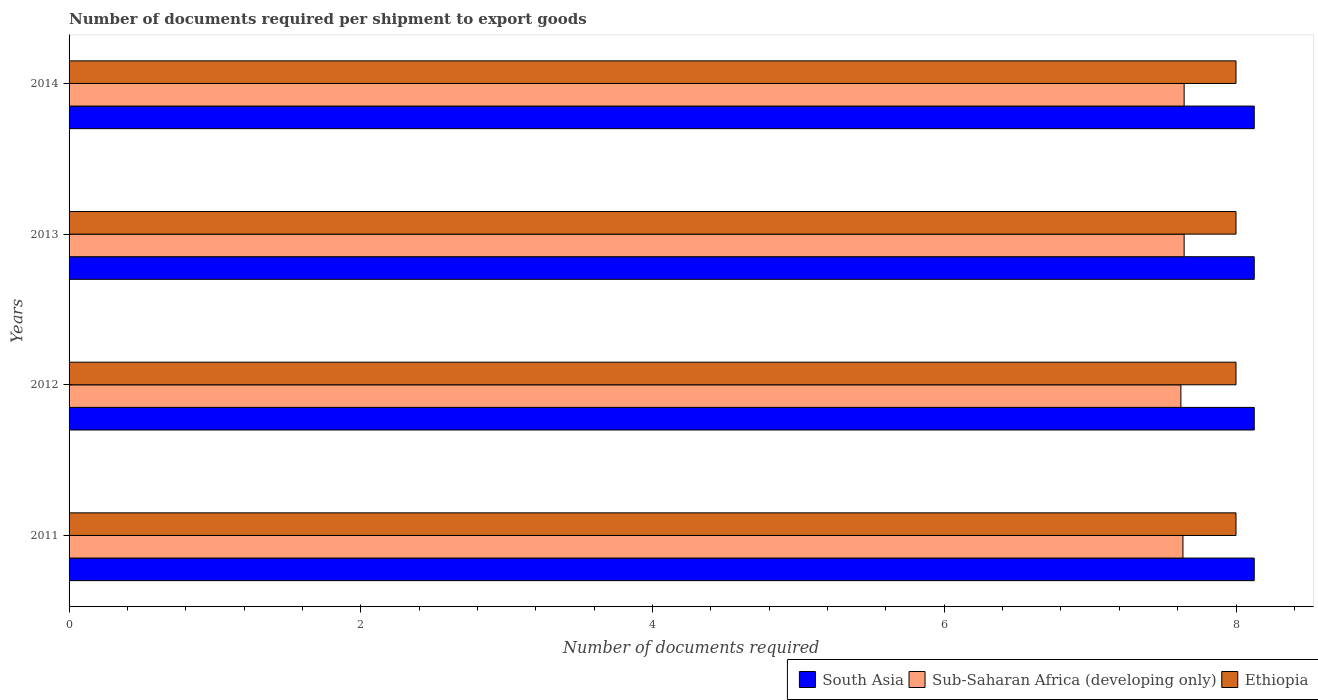How many different coloured bars are there?
Keep it short and to the point. 3. How many groups of bars are there?
Provide a succinct answer. 4. Are the number of bars on each tick of the Y-axis equal?
Make the answer very short. Yes. How many bars are there on the 1st tick from the top?
Ensure brevity in your answer.  3. How many bars are there on the 4th tick from the bottom?
Make the answer very short. 3. What is the label of the 3rd group of bars from the top?
Give a very brief answer. 2012. In how many cases, is the number of bars for a given year not equal to the number of legend labels?
Your answer should be very brief. 0. What is the number of documents required per shipment to export goods in South Asia in 2013?
Give a very brief answer. 8.12. Across all years, what is the maximum number of documents required per shipment to export goods in Sub-Saharan Africa (developing only)?
Offer a terse response. 7.64. Across all years, what is the minimum number of documents required per shipment to export goods in Ethiopia?
Your answer should be very brief. 8. What is the total number of documents required per shipment to export goods in Sub-Saharan Africa (developing only) in the graph?
Give a very brief answer. 30.55. What is the difference between the number of documents required per shipment to export goods in Sub-Saharan Africa (developing only) in 2014 and the number of documents required per shipment to export goods in South Asia in 2012?
Provide a short and direct response. -0.48. What is the average number of documents required per shipment to export goods in Sub-Saharan Africa (developing only) per year?
Offer a very short reply. 7.64. In the year 2014, what is the difference between the number of documents required per shipment to export goods in Sub-Saharan Africa (developing only) and number of documents required per shipment to export goods in Ethiopia?
Your answer should be very brief. -0.36. In how many years, is the number of documents required per shipment to export goods in Ethiopia greater than 7.6 ?
Make the answer very short. 4. Is the number of documents required per shipment to export goods in South Asia in 2012 less than that in 2013?
Provide a short and direct response. No. Is the difference between the number of documents required per shipment to export goods in Sub-Saharan Africa (developing only) in 2013 and 2014 greater than the difference between the number of documents required per shipment to export goods in Ethiopia in 2013 and 2014?
Provide a succinct answer. No. What is the difference between the highest and the lowest number of documents required per shipment to export goods in Sub-Saharan Africa (developing only)?
Your answer should be very brief. 0.02. Is the sum of the number of documents required per shipment to export goods in Sub-Saharan Africa (developing only) in 2012 and 2013 greater than the maximum number of documents required per shipment to export goods in South Asia across all years?
Provide a short and direct response. Yes. What does the 3rd bar from the top in 2013 represents?
Offer a terse response. South Asia. What does the 3rd bar from the bottom in 2014 represents?
Your answer should be compact. Ethiopia. Is it the case that in every year, the sum of the number of documents required per shipment to export goods in Sub-Saharan Africa (developing only) and number of documents required per shipment to export goods in South Asia is greater than the number of documents required per shipment to export goods in Ethiopia?
Provide a short and direct response. Yes. How many bars are there?
Provide a succinct answer. 12. How many years are there in the graph?
Give a very brief answer. 4. What is the difference between two consecutive major ticks on the X-axis?
Ensure brevity in your answer.  2. Are the values on the major ticks of X-axis written in scientific E-notation?
Your answer should be compact. No. Does the graph contain grids?
Provide a succinct answer. No. How many legend labels are there?
Provide a short and direct response. 3. How are the legend labels stacked?
Make the answer very short. Horizontal. What is the title of the graph?
Your answer should be compact. Number of documents required per shipment to export goods. What is the label or title of the X-axis?
Provide a succinct answer. Number of documents required. What is the label or title of the Y-axis?
Keep it short and to the point. Years. What is the Number of documents required in South Asia in 2011?
Provide a short and direct response. 8.12. What is the Number of documents required in Sub-Saharan Africa (developing only) in 2011?
Your answer should be compact. 7.64. What is the Number of documents required of South Asia in 2012?
Ensure brevity in your answer.  8.12. What is the Number of documents required of Sub-Saharan Africa (developing only) in 2012?
Ensure brevity in your answer.  7.62. What is the Number of documents required in South Asia in 2013?
Your response must be concise. 8.12. What is the Number of documents required in Sub-Saharan Africa (developing only) in 2013?
Ensure brevity in your answer.  7.64. What is the Number of documents required of South Asia in 2014?
Keep it short and to the point. 8.12. What is the Number of documents required in Sub-Saharan Africa (developing only) in 2014?
Make the answer very short. 7.64. Across all years, what is the maximum Number of documents required of South Asia?
Ensure brevity in your answer.  8.12. Across all years, what is the maximum Number of documents required of Sub-Saharan Africa (developing only)?
Provide a succinct answer. 7.64. Across all years, what is the minimum Number of documents required in South Asia?
Ensure brevity in your answer.  8.12. Across all years, what is the minimum Number of documents required in Sub-Saharan Africa (developing only)?
Offer a terse response. 7.62. Across all years, what is the minimum Number of documents required in Ethiopia?
Keep it short and to the point. 8. What is the total Number of documents required in South Asia in the graph?
Make the answer very short. 32.5. What is the total Number of documents required in Sub-Saharan Africa (developing only) in the graph?
Offer a very short reply. 30.55. What is the total Number of documents required of Ethiopia in the graph?
Provide a succinct answer. 32. What is the difference between the Number of documents required of Sub-Saharan Africa (developing only) in 2011 and that in 2012?
Your answer should be compact. 0.01. What is the difference between the Number of documents required in Sub-Saharan Africa (developing only) in 2011 and that in 2013?
Your response must be concise. -0.01. What is the difference between the Number of documents required of Sub-Saharan Africa (developing only) in 2011 and that in 2014?
Keep it short and to the point. -0.01. What is the difference between the Number of documents required of Sub-Saharan Africa (developing only) in 2012 and that in 2013?
Provide a short and direct response. -0.02. What is the difference between the Number of documents required of Ethiopia in 2012 and that in 2013?
Provide a short and direct response. 0. What is the difference between the Number of documents required in South Asia in 2012 and that in 2014?
Your response must be concise. 0. What is the difference between the Number of documents required in Sub-Saharan Africa (developing only) in 2012 and that in 2014?
Keep it short and to the point. -0.02. What is the difference between the Number of documents required in Ethiopia in 2012 and that in 2014?
Offer a very short reply. 0. What is the difference between the Number of documents required of South Asia in 2013 and that in 2014?
Give a very brief answer. 0. What is the difference between the Number of documents required of South Asia in 2011 and the Number of documents required of Sub-Saharan Africa (developing only) in 2012?
Offer a terse response. 0.5. What is the difference between the Number of documents required of Sub-Saharan Africa (developing only) in 2011 and the Number of documents required of Ethiopia in 2012?
Your answer should be very brief. -0.36. What is the difference between the Number of documents required in South Asia in 2011 and the Number of documents required in Sub-Saharan Africa (developing only) in 2013?
Your response must be concise. 0.48. What is the difference between the Number of documents required in Sub-Saharan Africa (developing only) in 2011 and the Number of documents required in Ethiopia in 2013?
Give a very brief answer. -0.36. What is the difference between the Number of documents required of South Asia in 2011 and the Number of documents required of Sub-Saharan Africa (developing only) in 2014?
Offer a very short reply. 0.48. What is the difference between the Number of documents required of Sub-Saharan Africa (developing only) in 2011 and the Number of documents required of Ethiopia in 2014?
Offer a terse response. -0.36. What is the difference between the Number of documents required of South Asia in 2012 and the Number of documents required of Sub-Saharan Africa (developing only) in 2013?
Provide a short and direct response. 0.48. What is the difference between the Number of documents required in South Asia in 2012 and the Number of documents required in Ethiopia in 2013?
Ensure brevity in your answer.  0.12. What is the difference between the Number of documents required of Sub-Saharan Africa (developing only) in 2012 and the Number of documents required of Ethiopia in 2013?
Offer a very short reply. -0.38. What is the difference between the Number of documents required of South Asia in 2012 and the Number of documents required of Sub-Saharan Africa (developing only) in 2014?
Make the answer very short. 0.48. What is the difference between the Number of documents required in South Asia in 2012 and the Number of documents required in Ethiopia in 2014?
Make the answer very short. 0.12. What is the difference between the Number of documents required in Sub-Saharan Africa (developing only) in 2012 and the Number of documents required in Ethiopia in 2014?
Your answer should be very brief. -0.38. What is the difference between the Number of documents required in South Asia in 2013 and the Number of documents required in Sub-Saharan Africa (developing only) in 2014?
Your answer should be very brief. 0.48. What is the difference between the Number of documents required in Sub-Saharan Africa (developing only) in 2013 and the Number of documents required in Ethiopia in 2014?
Give a very brief answer. -0.36. What is the average Number of documents required in South Asia per year?
Provide a short and direct response. 8.12. What is the average Number of documents required of Sub-Saharan Africa (developing only) per year?
Give a very brief answer. 7.64. What is the average Number of documents required in Ethiopia per year?
Keep it short and to the point. 8. In the year 2011, what is the difference between the Number of documents required in South Asia and Number of documents required in Sub-Saharan Africa (developing only)?
Offer a terse response. 0.49. In the year 2011, what is the difference between the Number of documents required of South Asia and Number of documents required of Ethiopia?
Make the answer very short. 0.12. In the year 2011, what is the difference between the Number of documents required in Sub-Saharan Africa (developing only) and Number of documents required in Ethiopia?
Provide a short and direct response. -0.36. In the year 2012, what is the difference between the Number of documents required of South Asia and Number of documents required of Sub-Saharan Africa (developing only)?
Offer a terse response. 0.5. In the year 2012, what is the difference between the Number of documents required of South Asia and Number of documents required of Ethiopia?
Make the answer very short. 0.12. In the year 2012, what is the difference between the Number of documents required of Sub-Saharan Africa (developing only) and Number of documents required of Ethiopia?
Give a very brief answer. -0.38. In the year 2013, what is the difference between the Number of documents required in South Asia and Number of documents required in Sub-Saharan Africa (developing only)?
Make the answer very short. 0.48. In the year 2013, what is the difference between the Number of documents required of South Asia and Number of documents required of Ethiopia?
Ensure brevity in your answer.  0.12. In the year 2013, what is the difference between the Number of documents required of Sub-Saharan Africa (developing only) and Number of documents required of Ethiopia?
Make the answer very short. -0.36. In the year 2014, what is the difference between the Number of documents required of South Asia and Number of documents required of Sub-Saharan Africa (developing only)?
Provide a short and direct response. 0.48. In the year 2014, what is the difference between the Number of documents required in South Asia and Number of documents required in Ethiopia?
Offer a very short reply. 0.12. In the year 2014, what is the difference between the Number of documents required in Sub-Saharan Africa (developing only) and Number of documents required in Ethiopia?
Make the answer very short. -0.36. What is the ratio of the Number of documents required of Ethiopia in 2011 to that in 2012?
Give a very brief answer. 1. What is the ratio of the Number of documents required of Ethiopia in 2011 to that in 2013?
Provide a short and direct response. 1. What is the ratio of the Number of documents required of South Asia in 2011 to that in 2014?
Ensure brevity in your answer.  1. What is the ratio of the Number of documents required in Sub-Saharan Africa (developing only) in 2011 to that in 2014?
Ensure brevity in your answer.  1. What is the ratio of the Number of documents required of South Asia in 2012 to that in 2013?
Ensure brevity in your answer.  1. What is the ratio of the Number of documents required in Sub-Saharan Africa (developing only) in 2012 to that in 2013?
Provide a succinct answer. 1. What is the ratio of the Number of documents required in Ethiopia in 2012 to that in 2014?
Your response must be concise. 1. What is the ratio of the Number of documents required in South Asia in 2013 to that in 2014?
Offer a terse response. 1. What is the ratio of the Number of documents required in Sub-Saharan Africa (developing only) in 2013 to that in 2014?
Provide a short and direct response. 1. What is the ratio of the Number of documents required of Ethiopia in 2013 to that in 2014?
Make the answer very short. 1. What is the difference between the highest and the second highest Number of documents required in South Asia?
Offer a terse response. 0. What is the difference between the highest and the lowest Number of documents required of Sub-Saharan Africa (developing only)?
Offer a terse response. 0.02. 